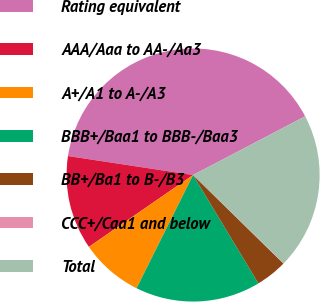Convert chart to OTSL. <chart><loc_0><loc_0><loc_500><loc_500><pie_chart><fcel>Rating equivalent<fcel>AAA/Aaa to AA-/Aa3<fcel>A+/A1 to A-/A3<fcel>BBB+/Baa1 to BBB-/Baa3<fcel>BB+/Ba1 to B-/B3<fcel>CCC+/Caa1 and below<fcel>Total<nl><fcel>39.93%<fcel>12.01%<fcel>8.02%<fcel>16.0%<fcel>4.03%<fcel>0.04%<fcel>19.98%<nl></chart> 